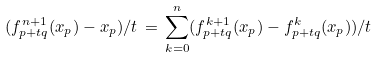Convert formula to latex. <formula><loc_0><loc_0><loc_500><loc_500>( f ^ { n + 1 } _ { p + t q } ( x _ { p } ) - x _ { p } ) / t \, = \, \sum _ { k = 0 } ^ { n } ( f _ { p + t q } ^ { k + 1 } ( x _ { p } ) - f ^ { k } _ { p + t q } ( x _ { p } ) ) / t</formula> 